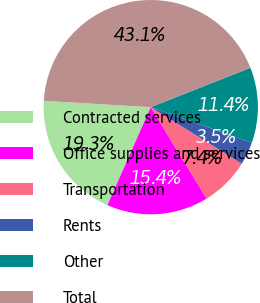Convert chart to OTSL. <chart><loc_0><loc_0><loc_500><loc_500><pie_chart><fcel>Contracted services<fcel>Office supplies and services<fcel>Transportation<fcel>Rents<fcel>Other<fcel>Total<nl><fcel>19.31%<fcel>15.35%<fcel>7.42%<fcel>3.46%<fcel>11.38%<fcel>43.08%<nl></chart> 